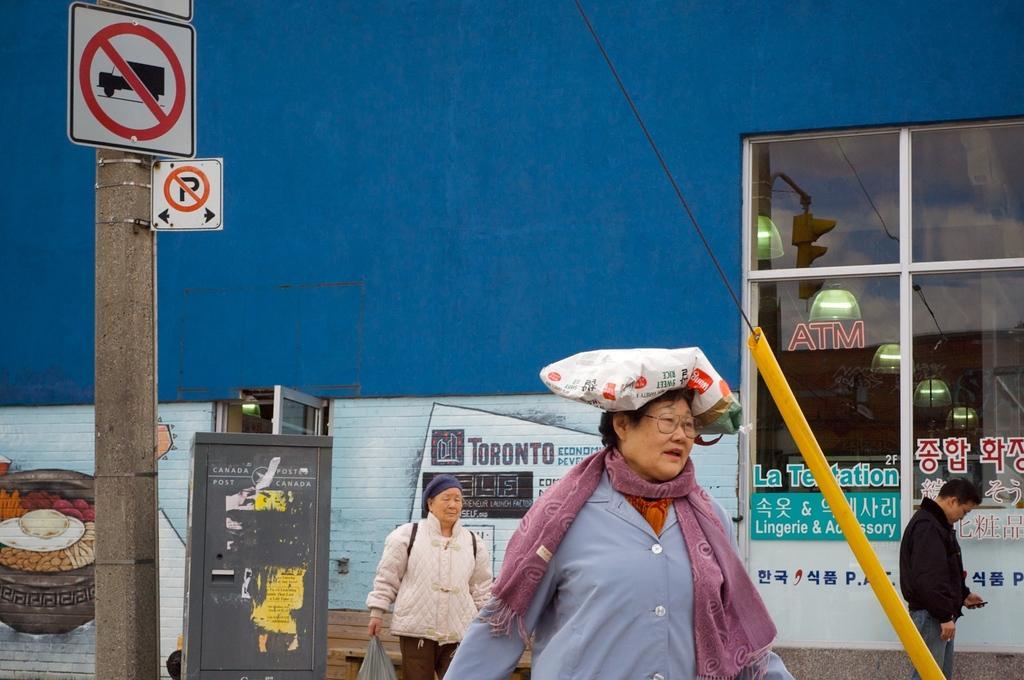Please provide a concise description of this image. In this picture I can see caution boards on the left side. I can see people standing. I can see a person holding telephone on the right side. I can see glass windows. I can see the wall. 